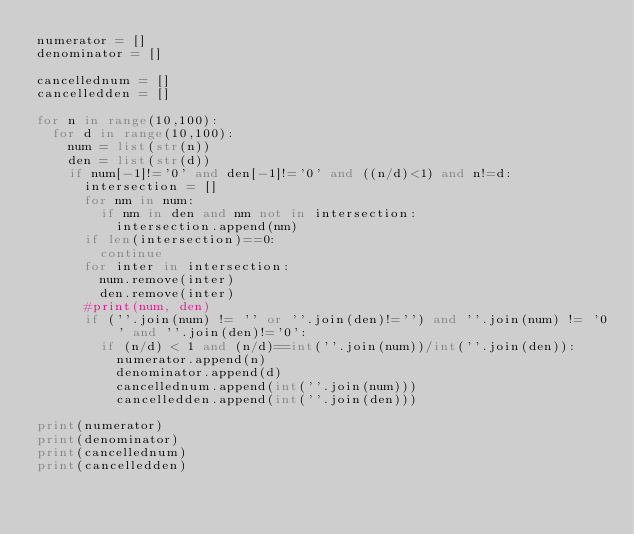Convert code to text. <code><loc_0><loc_0><loc_500><loc_500><_Python_>numerator = []
denominator = []

cancellednum = []
cancelledden = []

for n in range(10,100):
	for d in range(10,100):
		num = list(str(n))
		den = list(str(d))
		if num[-1]!='0' and den[-1]!='0' and ((n/d)<1) and n!=d:
			intersection = []
			for nm in num:
				if nm in den and nm not in intersection:
					intersection.append(nm)
			if len(intersection)==0:
				continue
			for inter in intersection:
				num.remove(inter)
				den.remove(inter)
			#print(num, den)
			if (''.join(num) != '' or ''.join(den)!='') and ''.join(num) != '0' and ''.join(den)!='0':
				if (n/d) < 1 and (n/d)==int(''.join(num))/int(''.join(den)):
					numerator.append(n)
					denominator.append(d)
					cancellednum.append(int(''.join(num)))
					cancelledden.append(int(''.join(den)))

print(numerator)
print(denominator)
print(cancellednum)
print(cancelledden)





</code> 